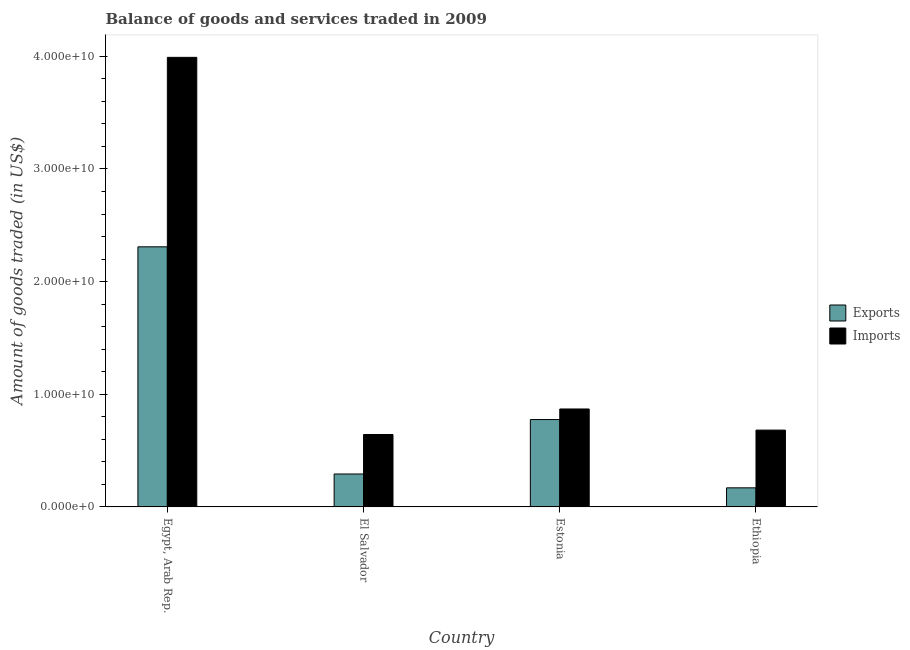How many groups of bars are there?
Keep it short and to the point. 4. Are the number of bars per tick equal to the number of legend labels?
Ensure brevity in your answer.  Yes. Are the number of bars on each tick of the X-axis equal?
Make the answer very short. Yes. How many bars are there on the 1st tick from the left?
Your response must be concise. 2. What is the label of the 2nd group of bars from the left?
Keep it short and to the point. El Salvador. What is the amount of goods exported in El Salvador?
Keep it short and to the point. 2.92e+09. Across all countries, what is the maximum amount of goods exported?
Provide a short and direct response. 2.31e+1. Across all countries, what is the minimum amount of goods imported?
Offer a very short reply. 6.43e+09. In which country was the amount of goods imported maximum?
Offer a very short reply. Egypt, Arab Rep. In which country was the amount of goods exported minimum?
Make the answer very short. Ethiopia. What is the total amount of goods imported in the graph?
Offer a terse response. 6.19e+1. What is the difference between the amount of goods exported in Estonia and that in Ethiopia?
Offer a terse response. 6.06e+09. What is the difference between the amount of goods exported in Estonia and the amount of goods imported in El Salvador?
Provide a short and direct response. 1.33e+09. What is the average amount of goods imported per country?
Make the answer very short. 1.55e+1. What is the difference between the amount of goods exported and amount of goods imported in Estonia?
Your answer should be very brief. -9.38e+08. In how many countries, is the amount of goods exported greater than 4000000000 US$?
Provide a short and direct response. 2. What is the ratio of the amount of goods exported in Egypt, Arab Rep. to that in Estonia?
Ensure brevity in your answer.  2.98. What is the difference between the highest and the second highest amount of goods imported?
Offer a very short reply. 3.12e+1. What is the difference between the highest and the lowest amount of goods imported?
Provide a succinct answer. 3.35e+1. In how many countries, is the amount of goods imported greater than the average amount of goods imported taken over all countries?
Make the answer very short. 1. What does the 1st bar from the left in Ethiopia represents?
Your answer should be compact. Exports. What does the 1st bar from the right in Ethiopia represents?
Provide a succinct answer. Imports. How many bars are there?
Keep it short and to the point. 8. What is the difference between two consecutive major ticks on the Y-axis?
Your answer should be very brief. 1.00e+1. Does the graph contain grids?
Ensure brevity in your answer.  No. What is the title of the graph?
Your response must be concise. Balance of goods and services traded in 2009. What is the label or title of the Y-axis?
Provide a short and direct response. Amount of goods traded (in US$). What is the Amount of goods traded (in US$) in Exports in Egypt, Arab Rep.?
Your answer should be compact. 2.31e+1. What is the Amount of goods traded (in US$) of Imports in Egypt, Arab Rep.?
Your response must be concise. 3.99e+1. What is the Amount of goods traded (in US$) of Exports in El Salvador?
Your answer should be very brief. 2.92e+09. What is the Amount of goods traded (in US$) in Imports in El Salvador?
Give a very brief answer. 6.43e+09. What is the Amount of goods traded (in US$) in Exports in Estonia?
Your answer should be compact. 7.76e+09. What is the Amount of goods traded (in US$) in Imports in Estonia?
Offer a very short reply. 8.69e+09. What is the Amount of goods traded (in US$) of Exports in Ethiopia?
Make the answer very short. 1.69e+09. What is the Amount of goods traded (in US$) of Imports in Ethiopia?
Keep it short and to the point. 6.82e+09. Across all countries, what is the maximum Amount of goods traded (in US$) of Exports?
Give a very brief answer. 2.31e+1. Across all countries, what is the maximum Amount of goods traded (in US$) in Imports?
Provide a succinct answer. 3.99e+1. Across all countries, what is the minimum Amount of goods traded (in US$) in Exports?
Give a very brief answer. 1.69e+09. Across all countries, what is the minimum Amount of goods traded (in US$) of Imports?
Provide a short and direct response. 6.43e+09. What is the total Amount of goods traded (in US$) in Exports in the graph?
Your answer should be compact. 3.55e+1. What is the total Amount of goods traded (in US$) of Imports in the graph?
Your answer should be compact. 6.19e+1. What is the difference between the Amount of goods traded (in US$) of Exports in Egypt, Arab Rep. and that in El Salvador?
Ensure brevity in your answer.  2.02e+1. What is the difference between the Amount of goods traded (in US$) in Imports in Egypt, Arab Rep. and that in El Salvador?
Your answer should be compact. 3.35e+1. What is the difference between the Amount of goods traded (in US$) in Exports in Egypt, Arab Rep. and that in Estonia?
Provide a succinct answer. 1.53e+1. What is the difference between the Amount of goods traded (in US$) of Imports in Egypt, Arab Rep. and that in Estonia?
Your answer should be compact. 3.12e+1. What is the difference between the Amount of goods traded (in US$) of Exports in Egypt, Arab Rep. and that in Ethiopia?
Provide a succinct answer. 2.14e+1. What is the difference between the Amount of goods traded (in US$) of Imports in Egypt, Arab Rep. and that in Ethiopia?
Offer a terse response. 3.31e+1. What is the difference between the Amount of goods traded (in US$) of Exports in El Salvador and that in Estonia?
Provide a short and direct response. -4.83e+09. What is the difference between the Amount of goods traded (in US$) in Imports in El Salvador and that in Estonia?
Offer a very short reply. -2.26e+09. What is the difference between the Amount of goods traded (in US$) in Exports in El Salvador and that in Ethiopia?
Provide a short and direct response. 1.23e+09. What is the difference between the Amount of goods traded (in US$) of Imports in El Salvador and that in Ethiopia?
Your answer should be very brief. -3.89e+08. What is the difference between the Amount of goods traded (in US$) in Exports in Estonia and that in Ethiopia?
Keep it short and to the point. 6.06e+09. What is the difference between the Amount of goods traded (in US$) of Imports in Estonia and that in Ethiopia?
Ensure brevity in your answer.  1.88e+09. What is the difference between the Amount of goods traded (in US$) of Exports in Egypt, Arab Rep. and the Amount of goods traded (in US$) of Imports in El Salvador?
Ensure brevity in your answer.  1.67e+1. What is the difference between the Amount of goods traded (in US$) in Exports in Egypt, Arab Rep. and the Amount of goods traded (in US$) in Imports in Estonia?
Ensure brevity in your answer.  1.44e+1. What is the difference between the Amount of goods traded (in US$) in Exports in Egypt, Arab Rep. and the Amount of goods traded (in US$) in Imports in Ethiopia?
Offer a very short reply. 1.63e+1. What is the difference between the Amount of goods traded (in US$) of Exports in El Salvador and the Amount of goods traded (in US$) of Imports in Estonia?
Your response must be concise. -5.77e+09. What is the difference between the Amount of goods traded (in US$) of Exports in El Salvador and the Amount of goods traded (in US$) of Imports in Ethiopia?
Your answer should be very brief. -3.90e+09. What is the difference between the Amount of goods traded (in US$) in Exports in Estonia and the Amount of goods traded (in US$) in Imports in Ethiopia?
Offer a terse response. 9.37e+08. What is the average Amount of goods traded (in US$) in Exports per country?
Your answer should be very brief. 8.87e+09. What is the average Amount of goods traded (in US$) of Imports per country?
Your answer should be compact. 1.55e+1. What is the difference between the Amount of goods traded (in US$) in Exports and Amount of goods traded (in US$) in Imports in Egypt, Arab Rep.?
Your answer should be very brief. -1.68e+1. What is the difference between the Amount of goods traded (in US$) of Exports and Amount of goods traded (in US$) of Imports in El Salvador?
Your answer should be very brief. -3.51e+09. What is the difference between the Amount of goods traded (in US$) of Exports and Amount of goods traded (in US$) of Imports in Estonia?
Offer a terse response. -9.38e+08. What is the difference between the Amount of goods traded (in US$) in Exports and Amount of goods traded (in US$) in Imports in Ethiopia?
Give a very brief answer. -5.12e+09. What is the ratio of the Amount of goods traded (in US$) of Exports in Egypt, Arab Rep. to that in El Salvador?
Offer a terse response. 7.9. What is the ratio of the Amount of goods traded (in US$) of Imports in Egypt, Arab Rep. to that in El Salvador?
Ensure brevity in your answer.  6.21. What is the ratio of the Amount of goods traded (in US$) of Exports in Egypt, Arab Rep. to that in Estonia?
Make the answer very short. 2.98. What is the ratio of the Amount of goods traded (in US$) of Imports in Egypt, Arab Rep. to that in Estonia?
Give a very brief answer. 4.59. What is the ratio of the Amount of goods traded (in US$) of Exports in Egypt, Arab Rep. to that in Ethiopia?
Keep it short and to the point. 13.62. What is the ratio of the Amount of goods traded (in US$) in Imports in Egypt, Arab Rep. to that in Ethiopia?
Provide a short and direct response. 5.85. What is the ratio of the Amount of goods traded (in US$) of Exports in El Salvador to that in Estonia?
Provide a short and direct response. 0.38. What is the ratio of the Amount of goods traded (in US$) of Imports in El Salvador to that in Estonia?
Your response must be concise. 0.74. What is the ratio of the Amount of goods traded (in US$) in Exports in El Salvador to that in Ethiopia?
Your answer should be very brief. 1.73. What is the ratio of the Amount of goods traded (in US$) of Imports in El Salvador to that in Ethiopia?
Your response must be concise. 0.94. What is the ratio of the Amount of goods traded (in US$) of Exports in Estonia to that in Ethiopia?
Offer a terse response. 4.58. What is the ratio of the Amount of goods traded (in US$) of Imports in Estonia to that in Ethiopia?
Provide a succinct answer. 1.27. What is the difference between the highest and the second highest Amount of goods traded (in US$) of Exports?
Your response must be concise. 1.53e+1. What is the difference between the highest and the second highest Amount of goods traded (in US$) of Imports?
Your answer should be compact. 3.12e+1. What is the difference between the highest and the lowest Amount of goods traded (in US$) in Exports?
Provide a succinct answer. 2.14e+1. What is the difference between the highest and the lowest Amount of goods traded (in US$) of Imports?
Offer a terse response. 3.35e+1. 